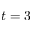<formula> <loc_0><loc_0><loc_500><loc_500>t = 3</formula> 